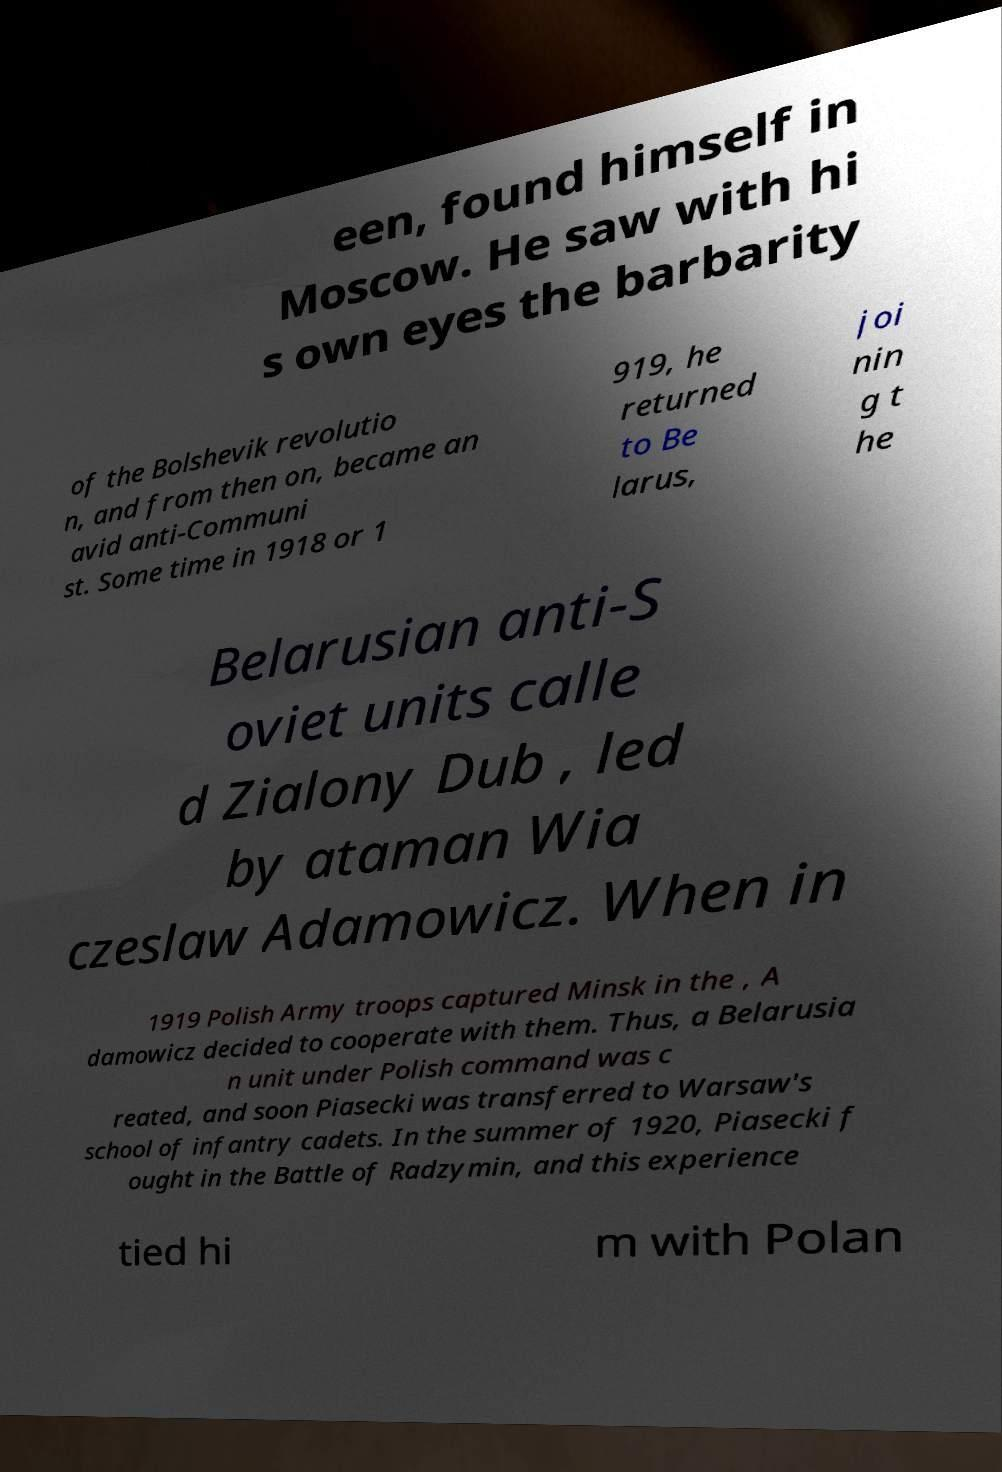Can you accurately transcribe the text from the provided image for me? een, found himself in Moscow. He saw with hi s own eyes the barbarity of the Bolshevik revolutio n, and from then on, became an avid anti-Communi st. Some time in 1918 or 1 919, he returned to Be larus, joi nin g t he Belarusian anti-S oviet units calle d Zialony Dub , led by ataman Wia czeslaw Adamowicz. When in 1919 Polish Army troops captured Minsk in the , A damowicz decided to cooperate with them. Thus, a Belarusia n unit under Polish command was c reated, and soon Piasecki was transferred to Warsaw's school of infantry cadets. In the summer of 1920, Piasecki f ought in the Battle of Radzymin, and this experience tied hi m with Polan 